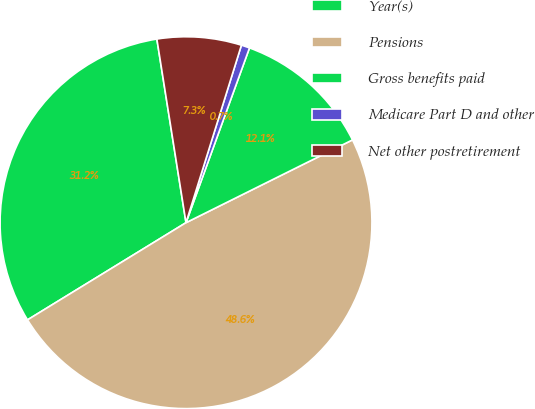<chart> <loc_0><loc_0><loc_500><loc_500><pie_chart><fcel>Year(s)<fcel>Pensions<fcel>Gross benefits paid<fcel>Medicare Part D and other<fcel>Net other postretirement<nl><fcel>31.25%<fcel>48.59%<fcel>12.11%<fcel>0.73%<fcel>7.32%<nl></chart> 